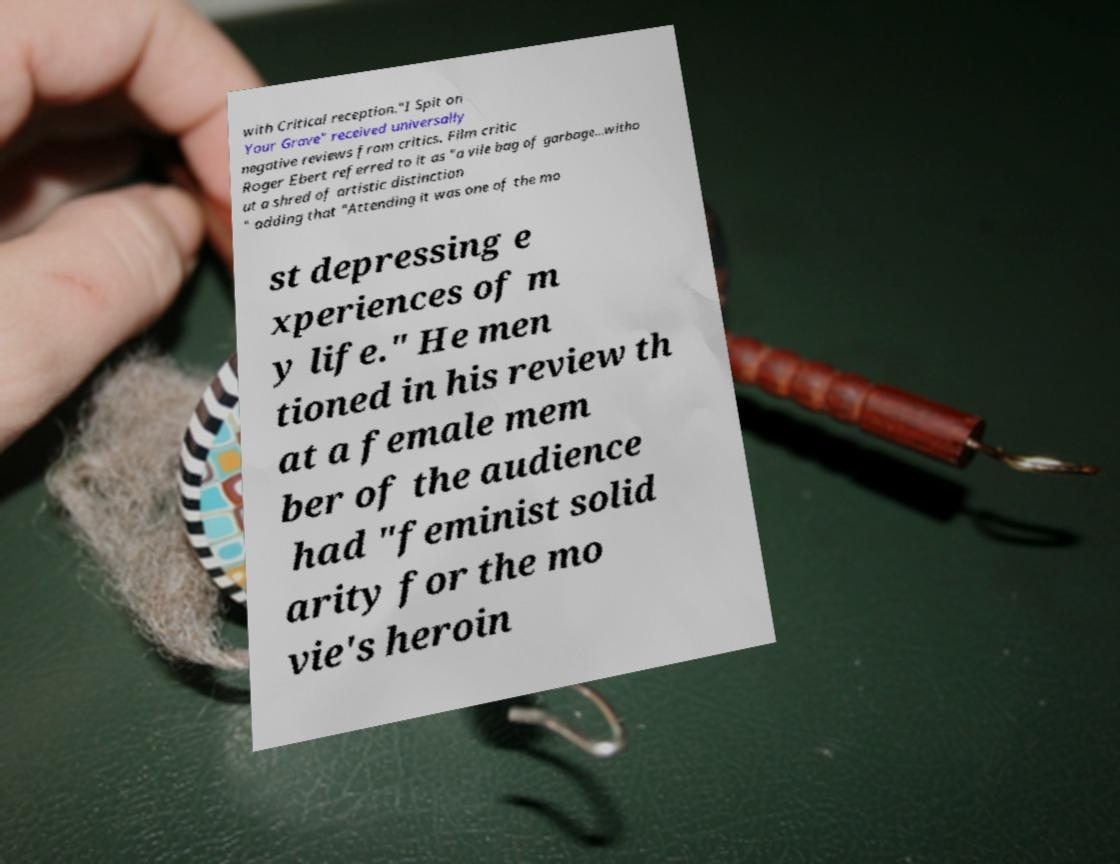For documentation purposes, I need the text within this image transcribed. Could you provide that? with Critical reception."I Spit on Your Grave" received universally negative reviews from critics. Film critic Roger Ebert referred to it as "a vile bag of garbage...witho ut a shred of artistic distinction " adding that "Attending it was one of the mo st depressing e xperiences of m y life." He men tioned in his review th at a female mem ber of the audience had "feminist solid arity for the mo vie's heroin 